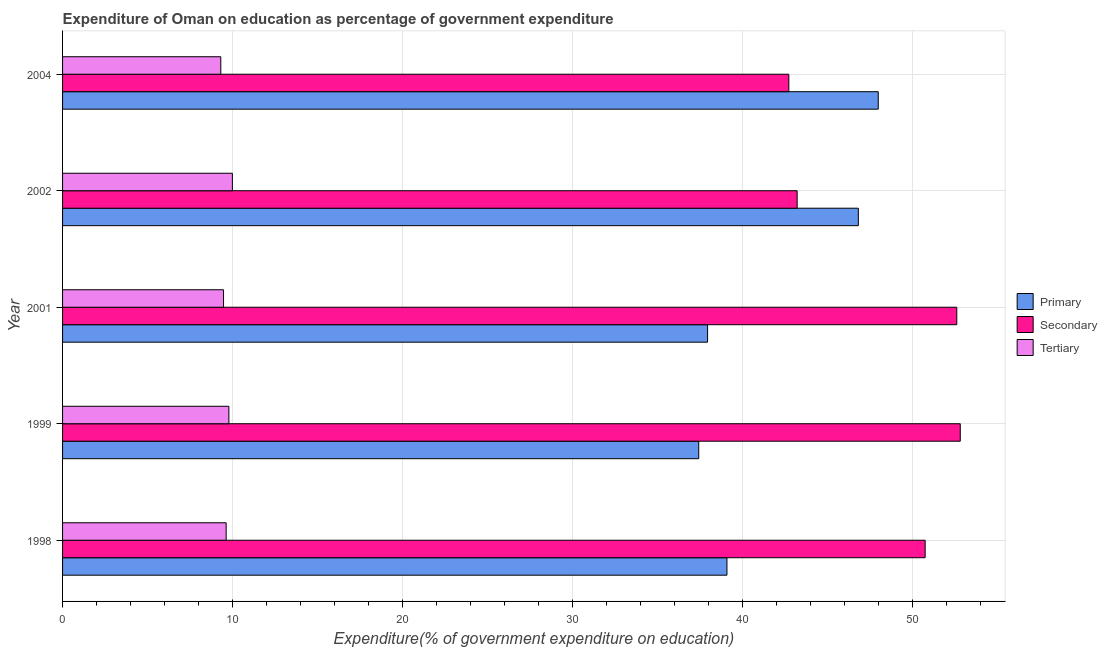Are the number of bars per tick equal to the number of legend labels?
Your answer should be very brief. Yes. How many bars are there on the 3rd tick from the top?
Provide a succinct answer. 3. What is the expenditure on tertiary education in 2002?
Provide a short and direct response. 9.99. Across all years, what is the maximum expenditure on secondary education?
Give a very brief answer. 52.8. Across all years, what is the minimum expenditure on tertiary education?
Your response must be concise. 9.31. In which year was the expenditure on tertiary education minimum?
Your answer should be very brief. 2004. What is the total expenditure on secondary education in the graph?
Your answer should be compact. 242.05. What is the difference between the expenditure on secondary education in 1999 and that in 2002?
Ensure brevity in your answer.  9.6. What is the difference between the expenditure on primary education in 2001 and the expenditure on secondary education in 1998?
Make the answer very short. -12.8. What is the average expenditure on primary education per year?
Provide a short and direct response. 41.84. In the year 2004, what is the difference between the expenditure on secondary education and expenditure on primary education?
Keep it short and to the point. -5.26. What is the ratio of the expenditure on tertiary education in 2001 to that in 2004?
Give a very brief answer. 1.02. Is the difference between the expenditure on secondary education in 1999 and 2004 greater than the difference between the expenditure on primary education in 1999 and 2004?
Keep it short and to the point. Yes. What is the difference between the highest and the second highest expenditure on tertiary education?
Your response must be concise. 0.21. What is the difference between the highest and the lowest expenditure on secondary education?
Offer a very short reply. 10.08. Is the sum of the expenditure on secondary education in 2001 and 2002 greater than the maximum expenditure on primary education across all years?
Provide a succinct answer. Yes. What does the 1st bar from the top in 2004 represents?
Your response must be concise. Tertiary. What does the 1st bar from the bottom in 2001 represents?
Give a very brief answer. Primary. Is it the case that in every year, the sum of the expenditure on primary education and expenditure on secondary education is greater than the expenditure on tertiary education?
Your answer should be compact. Yes. How many bars are there?
Provide a short and direct response. 15. Are all the bars in the graph horizontal?
Make the answer very short. Yes. How many years are there in the graph?
Ensure brevity in your answer.  5. What is the difference between two consecutive major ticks on the X-axis?
Your response must be concise. 10. Does the graph contain any zero values?
Make the answer very short. No. Does the graph contain grids?
Make the answer very short. Yes. What is the title of the graph?
Give a very brief answer. Expenditure of Oman on education as percentage of government expenditure. What is the label or title of the X-axis?
Keep it short and to the point. Expenditure(% of government expenditure on education). What is the label or title of the Y-axis?
Give a very brief answer. Year. What is the Expenditure(% of government expenditure on education) of Primary in 1998?
Provide a short and direct response. 39.08. What is the Expenditure(% of government expenditure on education) of Secondary in 1998?
Provide a short and direct response. 50.73. What is the Expenditure(% of government expenditure on education) of Tertiary in 1998?
Provide a succinct answer. 9.62. What is the Expenditure(% of government expenditure on education) of Primary in 1999?
Keep it short and to the point. 37.42. What is the Expenditure(% of government expenditure on education) in Secondary in 1999?
Your answer should be very brief. 52.8. What is the Expenditure(% of government expenditure on education) of Tertiary in 1999?
Offer a very short reply. 9.78. What is the Expenditure(% of government expenditure on education) of Primary in 2001?
Your answer should be very brief. 37.94. What is the Expenditure(% of government expenditure on education) of Secondary in 2001?
Provide a short and direct response. 52.59. What is the Expenditure(% of government expenditure on education) in Tertiary in 2001?
Keep it short and to the point. 9.47. What is the Expenditure(% of government expenditure on education) in Primary in 2002?
Keep it short and to the point. 46.81. What is the Expenditure(% of government expenditure on education) of Secondary in 2002?
Ensure brevity in your answer.  43.21. What is the Expenditure(% of government expenditure on education) in Tertiary in 2002?
Your answer should be very brief. 9.99. What is the Expenditure(% of government expenditure on education) in Primary in 2004?
Your response must be concise. 47.98. What is the Expenditure(% of government expenditure on education) of Secondary in 2004?
Ensure brevity in your answer.  42.72. What is the Expenditure(% of government expenditure on education) of Tertiary in 2004?
Keep it short and to the point. 9.31. Across all years, what is the maximum Expenditure(% of government expenditure on education) of Primary?
Make the answer very short. 47.98. Across all years, what is the maximum Expenditure(% of government expenditure on education) in Secondary?
Offer a very short reply. 52.8. Across all years, what is the maximum Expenditure(% of government expenditure on education) of Tertiary?
Provide a short and direct response. 9.99. Across all years, what is the minimum Expenditure(% of government expenditure on education) of Primary?
Offer a very short reply. 37.42. Across all years, what is the minimum Expenditure(% of government expenditure on education) of Secondary?
Keep it short and to the point. 42.72. Across all years, what is the minimum Expenditure(% of government expenditure on education) of Tertiary?
Make the answer very short. 9.31. What is the total Expenditure(% of government expenditure on education) of Primary in the graph?
Offer a very short reply. 209.22. What is the total Expenditure(% of government expenditure on education) in Secondary in the graph?
Provide a short and direct response. 242.05. What is the total Expenditure(% of government expenditure on education) in Tertiary in the graph?
Your answer should be very brief. 48.17. What is the difference between the Expenditure(% of government expenditure on education) in Primary in 1998 and that in 1999?
Your answer should be very brief. 1.66. What is the difference between the Expenditure(% of government expenditure on education) in Secondary in 1998 and that in 1999?
Offer a very short reply. -2.07. What is the difference between the Expenditure(% of government expenditure on education) in Tertiary in 1998 and that in 1999?
Provide a succinct answer. -0.16. What is the difference between the Expenditure(% of government expenditure on education) of Primary in 1998 and that in 2001?
Your answer should be compact. 1.14. What is the difference between the Expenditure(% of government expenditure on education) in Secondary in 1998 and that in 2001?
Ensure brevity in your answer.  -1.86. What is the difference between the Expenditure(% of government expenditure on education) in Tertiary in 1998 and that in 2001?
Your answer should be compact. 0.15. What is the difference between the Expenditure(% of government expenditure on education) of Primary in 1998 and that in 2002?
Your response must be concise. -7.73. What is the difference between the Expenditure(% of government expenditure on education) in Secondary in 1998 and that in 2002?
Offer a very short reply. 7.53. What is the difference between the Expenditure(% of government expenditure on education) of Tertiary in 1998 and that in 2002?
Provide a short and direct response. -0.37. What is the difference between the Expenditure(% of government expenditure on education) of Primary in 1998 and that in 2004?
Provide a succinct answer. -8.9. What is the difference between the Expenditure(% of government expenditure on education) in Secondary in 1998 and that in 2004?
Your answer should be very brief. 8.02. What is the difference between the Expenditure(% of government expenditure on education) of Tertiary in 1998 and that in 2004?
Provide a succinct answer. 0.32. What is the difference between the Expenditure(% of government expenditure on education) in Primary in 1999 and that in 2001?
Your response must be concise. -0.52. What is the difference between the Expenditure(% of government expenditure on education) of Secondary in 1999 and that in 2001?
Provide a succinct answer. 0.21. What is the difference between the Expenditure(% of government expenditure on education) in Tertiary in 1999 and that in 2001?
Keep it short and to the point. 0.31. What is the difference between the Expenditure(% of government expenditure on education) of Primary in 1999 and that in 2002?
Your answer should be very brief. -9.39. What is the difference between the Expenditure(% of government expenditure on education) in Secondary in 1999 and that in 2002?
Give a very brief answer. 9.59. What is the difference between the Expenditure(% of government expenditure on education) of Tertiary in 1999 and that in 2002?
Your answer should be compact. -0.21. What is the difference between the Expenditure(% of government expenditure on education) of Primary in 1999 and that in 2004?
Ensure brevity in your answer.  -10.56. What is the difference between the Expenditure(% of government expenditure on education) of Secondary in 1999 and that in 2004?
Provide a short and direct response. 10.08. What is the difference between the Expenditure(% of government expenditure on education) of Tertiary in 1999 and that in 2004?
Offer a terse response. 0.48. What is the difference between the Expenditure(% of government expenditure on education) in Primary in 2001 and that in 2002?
Make the answer very short. -8.87. What is the difference between the Expenditure(% of government expenditure on education) of Secondary in 2001 and that in 2002?
Your answer should be compact. 9.39. What is the difference between the Expenditure(% of government expenditure on education) of Tertiary in 2001 and that in 2002?
Your answer should be very brief. -0.52. What is the difference between the Expenditure(% of government expenditure on education) of Primary in 2001 and that in 2004?
Your response must be concise. -10.04. What is the difference between the Expenditure(% of government expenditure on education) of Secondary in 2001 and that in 2004?
Offer a very short reply. 9.88. What is the difference between the Expenditure(% of government expenditure on education) of Tertiary in 2001 and that in 2004?
Provide a succinct answer. 0.16. What is the difference between the Expenditure(% of government expenditure on education) of Primary in 2002 and that in 2004?
Make the answer very short. -1.17. What is the difference between the Expenditure(% of government expenditure on education) of Secondary in 2002 and that in 2004?
Provide a short and direct response. 0.49. What is the difference between the Expenditure(% of government expenditure on education) in Tertiary in 2002 and that in 2004?
Provide a short and direct response. 0.68. What is the difference between the Expenditure(% of government expenditure on education) in Primary in 1998 and the Expenditure(% of government expenditure on education) in Secondary in 1999?
Offer a very short reply. -13.72. What is the difference between the Expenditure(% of government expenditure on education) in Primary in 1998 and the Expenditure(% of government expenditure on education) in Tertiary in 1999?
Offer a terse response. 29.3. What is the difference between the Expenditure(% of government expenditure on education) in Secondary in 1998 and the Expenditure(% of government expenditure on education) in Tertiary in 1999?
Make the answer very short. 40.95. What is the difference between the Expenditure(% of government expenditure on education) in Primary in 1998 and the Expenditure(% of government expenditure on education) in Secondary in 2001?
Give a very brief answer. -13.52. What is the difference between the Expenditure(% of government expenditure on education) in Primary in 1998 and the Expenditure(% of government expenditure on education) in Tertiary in 2001?
Your response must be concise. 29.61. What is the difference between the Expenditure(% of government expenditure on education) of Secondary in 1998 and the Expenditure(% of government expenditure on education) of Tertiary in 2001?
Your answer should be very brief. 41.27. What is the difference between the Expenditure(% of government expenditure on education) of Primary in 1998 and the Expenditure(% of government expenditure on education) of Secondary in 2002?
Offer a terse response. -4.13. What is the difference between the Expenditure(% of government expenditure on education) in Primary in 1998 and the Expenditure(% of government expenditure on education) in Tertiary in 2002?
Provide a short and direct response. 29.09. What is the difference between the Expenditure(% of government expenditure on education) of Secondary in 1998 and the Expenditure(% of government expenditure on education) of Tertiary in 2002?
Your response must be concise. 40.75. What is the difference between the Expenditure(% of government expenditure on education) of Primary in 1998 and the Expenditure(% of government expenditure on education) of Secondary in 2004?
Offer a terse response. -3.64. What is the difference between the Expenditure(% of government expenditure on education) in Primary in 1998 and the Expenditure(% of government expenditure on education) in Tertiary in 2004?
Give a very brief answer. 29.77. What is the difference between the Expenditure(% of government expenditure on education) in Secondary in 1998 and the Expenditure(% of government expenditure on education) in Tertiary in 2004?
Keep it short and to the point. 41.43. What is the difference between the Expenditure(% of government expenditure on education) in Primary in 1999 and the Expenditure(% of government expenditure on education) in Secondary in 2001?
Provide a short and direct response. -15.18. What is the difference between the Expenditure(% of government expenditure on education) of Primary in 1999 and the Expenditure(% of government expenditure on education) of Tertiary in 2001?
Offer a terse response. 27.95. What is the difference between the Expenditure(% of government expenditure on education) of Secondary in 1999 and the Expenditure(% of government expenditure on education) of Tertiary in 2001?
Offer a very short reply. 43.33. What is the difference between the Expenditure(% of government expenditure on education) of Primary in 1999 and the Expenditure(% of government expenditure on education) of Secondary in 2002?
Your response must be concise. -5.79. What is the difference between the Expenditure(% of government expenditure on education) of Primary in 1999 and the Expenditure(% of government expenditure on education) of Tertiary in 2002?
Offer a terse response. 27.43. What is the difference between the Expenditure(% of government expenditure on education) in Secondary in 1999 and the Expenditure(% of government expenditure on education) in Tertiary in 2002?
Provide a short and direct response. 42.81. What is the difference between the Expenditure(% of government expenditure on education) in Primary in 1999 and the Expenditure(% of government expenditure on education) in Secondary in 2004?
Give a very brief answer. -5.3. What is the difference between the Expenditure(% of government expenditure on education) in Primary in 1999 and the Expenditure(% of government expenditure on education) in Tertiary in 2004?
Provide a short and direct response. 28.11. What is the difference between the Expenditure(% of government expenditure on education) in Secondary in 1999 and the Expenditure(% of government expenditure on education) in Tertiary in 2004?
Ensure brevity in your answer.  43.49. What is the difference between the Expenditure(% of government expenditure on education) of Primary in 2001 and the Expenditure(% of government expenditure on education) of Secondary in 2002?
Offer a terse response. -5.27. What is the difference between the Expenditure(% of government expenditure on education) of Primary in 2001 and the Expenditure(% of government expenditure on education) of Tertiary in 2002?
Keep it short and to the point. 27.95. What is the difference between the Expenditure(% of government expenditure on education) of Secondary in 2001 and the Expenditure(% of government expenditure on education) of Tertiary in 2002?
Provide a short and direct response. 42.61. What is the difference between the Expenditure(% of government expenditure on education) in Primary in 2001 and the Expenditure(% of government expenditure on education) in Secondary in 2004?
Ensure brevity in your answer.  -4.78. What is the difference between the Expenditure(% of government expenditure on education) of Primary in 2001 and the Expenditure(% of government expenditure on education) of Tertiary in 2004?
Give a very brief answer. 28.63. What is the difference between the Expenditure(% of government expenditure on education) of Secondary in 2001 and the Expenditure(% of government expenditure on education) of Tertiary in 2004?
Offer a terse response. 43.29. What is the difference between the Expenditure(% of government expenditure on education) in Primary in 2002 and the Expenditure(% of government expenditure on education) in Secondary in 2004?
Offer a very short reply. 4.09. What is the difference between the Expenditure(% of government expenditure on education) in Primary in 2002 and the Expenditure(% of government expenditure on education) in Tertiary in 2004?
Your answer should be very brief. 37.5. What is the difference between the Expenditure(% of government expenditure on education) of Secondary in 2002 and the Expenditure(% of government expenditure on education) of Tertiary in 2004?
Provide a succinct answer. 33.9. What is the average Expenditure(% of government expenditure on education) of Primary per year?
Your answer should be very brief. 41.84. What is the average Expenditure(% of government expenditure on education) in Secondary per year?
Your answer should be very brief. 48.41. What is the average Expenditure(% of government expenditure on education) in Tertiary per year?
Your answer should be compact. 9.63. In the year 1998, what is the difference between the Expenditure(% of government expenditure on education) in Primary and Expenditure(% of government expenditure on education) in Secondary?
Provide a succinct answer. -11.66. In the year 1998, what is the difference between the Expenditure(% of government expenditure on education) of Primary and Expenditure(% of government expenditure on education) of Tertiary?
Make the answer very short. 29.46. In the year 1998, what is the difference between the Expenditure(% of government expenditure on education) of Secondary and Expenditure(% of government expenditure on education) of Tertiary?
Make the answer very short. 41.11. In the year 1999, what is the difference between the Expenditure(% of government expenditure on education) in Primary and Expenditure(% of government expenditure on education) in Secondary?
Provide a succinct answer. -15.38. In the year 1999, what is the difference between the Expenditure(% of government expenditure on education) in Primary and Expenditure(% of government expenditure on education) in Tertiary?
Offer a very short reply. 27.64. In the year 1999, what is the difference between the Expenditure(% of government expenditure on education) of Secondary and Expenditure(% of government expenditure on education) of Tertiary?
Provide a short and direct response. 43.02. In the year 2001, what is the difference between the Expenditure(% of government expenditure on education) of Primary and Expenditure(% of government expenditure on education) of Secondary?
Provide a short and direct response. -14.66. In the year 2001, what is the difference between the Expenditure(% of government expenditure on education) in Primary and Expenditure(% of government expenditure on education) in Tertiary?
Provide a succinct answer. 28.47. In the year 2001, what is the difference between the Expenditure(% of government expenditure on education) in Secondary and Expenditure(% of government expenditure on education) in Tertiary?
Offer a terse response. 43.13. In the year 2002, what is the difference between the Expenditure(% of government expenditure on education) in Primary and Expenditure(% of government expenditure on education) in Secondary?
Provide a short and direct response. 3.6. In the year 2002, what is the difference between the Expenditure(% of government expenditure on education) of Primary and Expenditure(% of government expenditure on education) of Tertiary?
Give a very brief answer. 36.82. In the year 2002, what is the difference between the Expenditure(% of government expenditure on education) of Secondary and Expenditure(% of government expenditure on education) of Tertiary?
Make the answer very short. 33.22. In the year 2004, what is the difference between the Expenditure(% of government expenditure on education) in Primary and Expenditure(% of government expenditure on education) in Secondary?
Offer a terse response. 5.26. In the year 2004, what is the difference between the Expenditure(% of government expenditure on education) of Primary and Expenditure(% of government expenditure on education) of Tertiary?
Provide a short and direct response. 38.67. In the year 2004, what is the difference between the Expenditure(% of government expenditure on education) in Secondary and Expenditure(% of government expenditure on education) in Tertiary?
Provide a succinct answer. 33.41. What is the ratio of the Expenditure(% of government expenditure on education) in Primary in 1998 to that in 1999?
Offer a very short reply. 1.04. What is the ratio of the Expenditure(% of government expenditure on education) of Secondary in 1998 to that in 1999?
Provide a succinct answer. 0.96. What is the ratio of the Expenditure(% of government expenditure on education) of Tertiary in 1998 to that in 1999?
Offer a very short reply. 0.98. What is the ratio of the Expenditure(% of government expenditure on education) in Secondary in 1998 to that in 2001?
Provide a succinct answer. 0.96. What is the ratio of the Expenditure(% of government expenditure on education) of Tertiary in 1998 to that in 2001?
Your answer should be compact. 1.02. What is the ratio of the Expenditure(% of government expenditure on education) of Primary in 1998 to that in 2002?
Provide a succinct answer. 0.83. What is the ratio of the Expenditure(% of government expenditure on education) in Secondary in 1998 to that in 2002?
Provide a succinct answer. 1.17. What is the ratio of the Expenditure(% of government expenditure on education) in Tertiary in 1998 to that in 2002?
Offer a terse response. 0.96. What is the ratio of the Expenditure(% of government expenditure on education) of Primary in 1998 to that in 2004?
Make the answer very short. 0.81. What is the ratio of the Expenditure(% of government expenditure on education) in Secondary in 1998 to that in 2004?
Give a very brief answer. 1.19. What is the ratio of the Expenditure(% of government expenditure on education) of Tertiary in 1998 to that in 2004?
Ensure brevity in your answer.  1.03. What is the ratio of the Expenditure(% of government expenditure on education) in Primary in 1999 to that in 2001?
Offer a very short reply. 0.99. What is the ratio of the Expenditure(% of government expenditure on education) of Secondary in 1999 to that in 2001?
Provide a succinct answer. 1. What is the ratio of the Expenditure(% of government expenditure on education) in Tertiary in 1999 to that in 2001?
Ensure brevity in your answer.  1.03. What is the ratio of the Expenditure(% of government expenditure on education) of Primary in 1999 to that in 2002?
Offer a very short reply. 0.8. What is the ratio of the Expenditure(% of government expenditure on education) in Secondary in 1999 to that in 2002?
Make the answer very short. 1.22. What is the ratio of the Expenditure(% of government expenditure on education) in Tertiary in 1999 to that in 2002?
Your answer should be compact. 0.98. What is the ratio of the Expenditure(% of government expenditure on education) of Primary in 1999 to that in 2004?
Provide a short and direct response. 0.78. What is the ratio of the Expenditure(% of government expenditure on education) of Secondary in 1999 to that in 2004?
Offer a terse response. 1.24. What is the ratio of the Expenditure(% of government expenditure on education) in Tertiary in 1999 to that in 2004?
Make the answer very short. 1.05. What is the ratio of the Expenditure(% of government expenditure on education) in Primary in 2001 to that in 2002?
Your answer should be compact. 0.81. What is the ratio of the Expenditure(% of government expenditure on education) in Secondary in 2001 to that in 2002?
Offer a very short reply. 1.22. What is the ratio of the Expenditure(% of government expenditure on education) in Tertiary in 2001 to that in 2002?
Give a very brief answer. 0.95. What is the ratio of the Expenditure(% of government expenditure on education) of Primary in 2001 to that in 2004?
Offer a terse response. 0.79. What is the ratio of the Expenditure(% of government expenditure on education) of Secondary in 2001 to that in 2004?
Your response must be concise. 1.23. What is the ratio of the Expenditure(% of government expenditure on education) in Tertiary in 2001 to that in 2004?
Your answer should be compact. 1.02. What is the ratio of the Expenditure(% of government expenditure on education) in Primary in 2002 to that in 2004?
Your response must be concise. 0.98. What is the ratio of the Expenditure(% of government expenditure on education) of Secondary in 2002 to that in 2004?
Keep it short and to the point. 1.01. What is the ratio of the Expenditure(% of government expenditure on education) of Tertiary in 2002 to that in 2004?
Offer a terse response. 1.07. What is the difference between the highest and the second highest Expenditure(% of government expenditure on education) of Primary?
Keep it short and to the point. 1.17. What is the difference between the highest and the second highest Expenditure(% of government expenditure on education) in Secondary?
Give a very brief answer. 0.21. What is the difference between the highest and the second highest Expenditure(% of government expenditure on education) of Tertiary?
Give a very brief answer. 0.21. What is the difference between the highest and the lowest Expenditure(% of government expenditure on education) in Primary?
Provide a succinct answer. 10.56. What is the difference between the highest and the lowest Expenditure(% of government expenditure on education) in Secondary?
Your answer should be very brief. 10.08. What is the difference between the highest and the lowest Expenditure(% of government expenditure on education) of Tertiary?
Your answer should be compact. 0.68. 